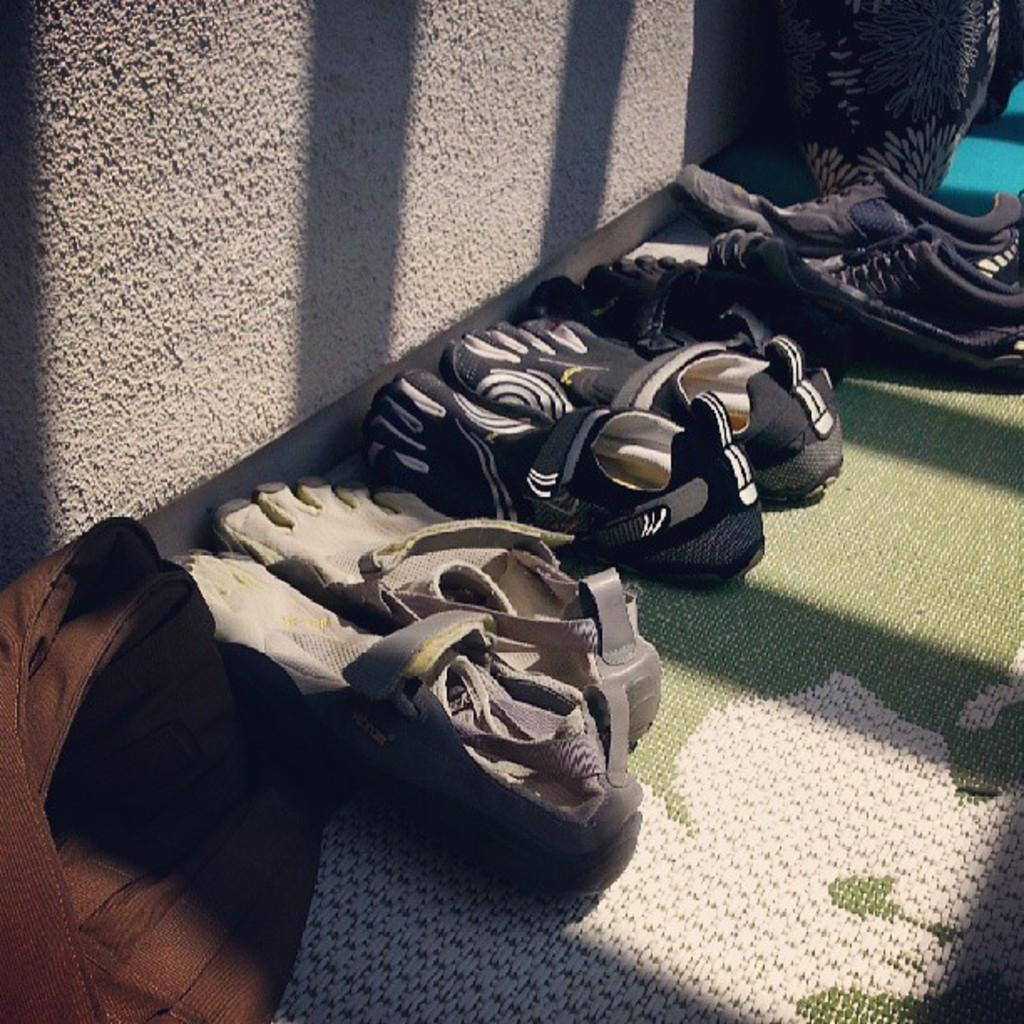What object is visible in the image that can be used for carrying items? There is a bag in the image that can be used for carrying items. What type of footwear is present in the image? There are shoes in the image. Where are the bag and shoes located in the image? The bag and shoes are arranged on a mat. What can be seen behind the bag and shoes in the image? There is a white wall in the background of the image. What action is the lake performing in the image? There is no lake present in the image, so no action can be attributed to it. 